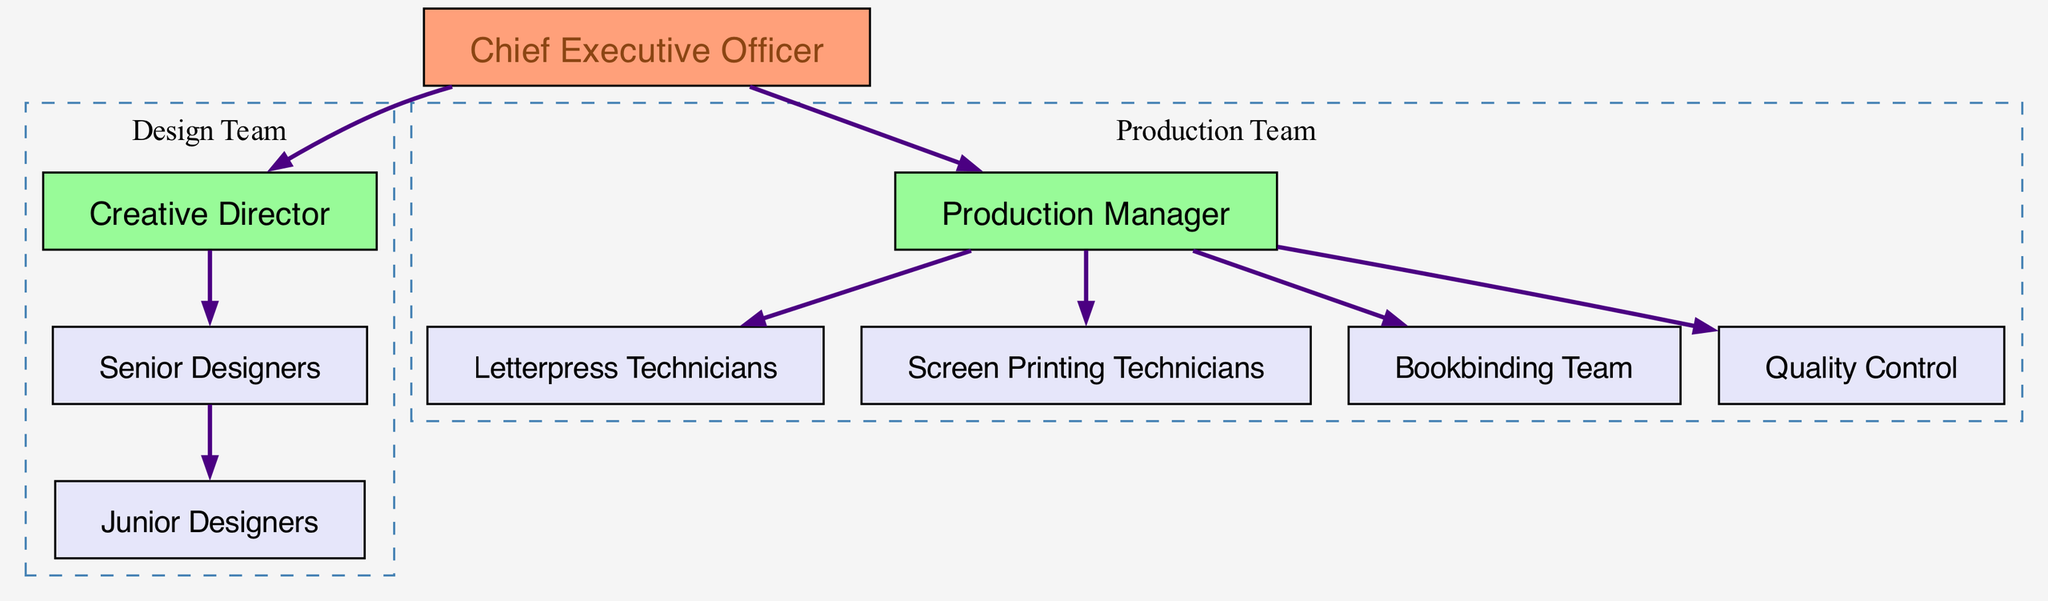What is the highest position in the organization? The highest position, denoted in the diagram, is the Chief Executive Officer (CEO), since it does not have any nodes pointing towards it, indicating that it is at the top of the hierarchy.
Answer: Chief Executive Officer Which team is responsible for production? The Production Team is represented by the Production Manager (PM) along with the Letterpress Technicians (LT), Screen Printing Technicians (ST), Bookbinding Team (BT), and Quality Control (QC) nodes, which are all connected to the PM.
Answer: Production Team How many total employees are involved in design? The Design Team consists of the Creative Director (CD), Senior Designers (SD), and Junior Designers (JD), making a total of three roles involved in design.
Answer: Three Which technician is linked directly under the Production Manager? The Letterpress Technicians (LT), Screen Printing Technicians (ST), Bookbinding Team (BT), and Quality Control (QC) all link directly beneath the Production Manager (PM), but the question specifies to name just one; thus, Letterpress Technicians is one of the linked groups.
Answer: Letterpress Technicians Who oversees the Senior Designers? The hierarchy indicates that the Creative Director (CD) directly oversees the Senior Designers (SD), as represented by the edge connecting the two in the diagram.
Answer: Creative Director What color is the node representing the Chief Executive Officer? The node for the Chief Executive Officer (CEO) is filled with a light coral color, which visually distinguishes it from other roles in the diagram.
Answer: Light coral How many teams are shown in the diagram? The diagram displays two main teams: the Design Team and the Production Team, each with their respective roles outlined within them.
Answer: Two Which position acts as a link between the CEO and the design team? The Creative Director (CD) serves as the connection between the Chief Executive Officer (CEO) and the Senior Designers (SD), as illustrated by the edges in the diagram.
Answer: Creative Director 